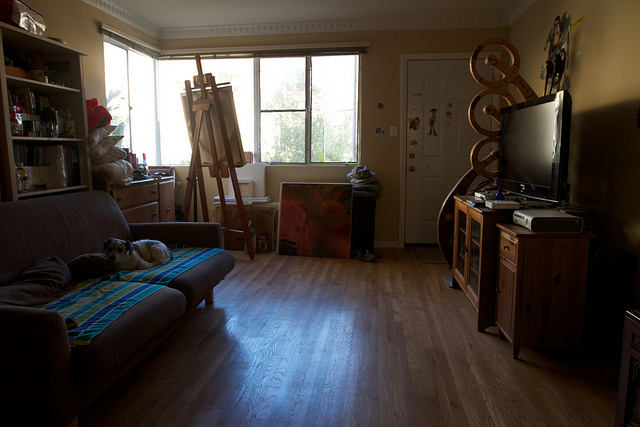Can you infer anything about the person who occupies this room? The person who spends time in this room seems to have a passion for the arts, indicated by the art supplies and musical instrument. They may appreciate comfort, as evidenced by the cozy sofa with a blanket. The organized yet personal nature of the space indicates someone who takes care in their living environment. 